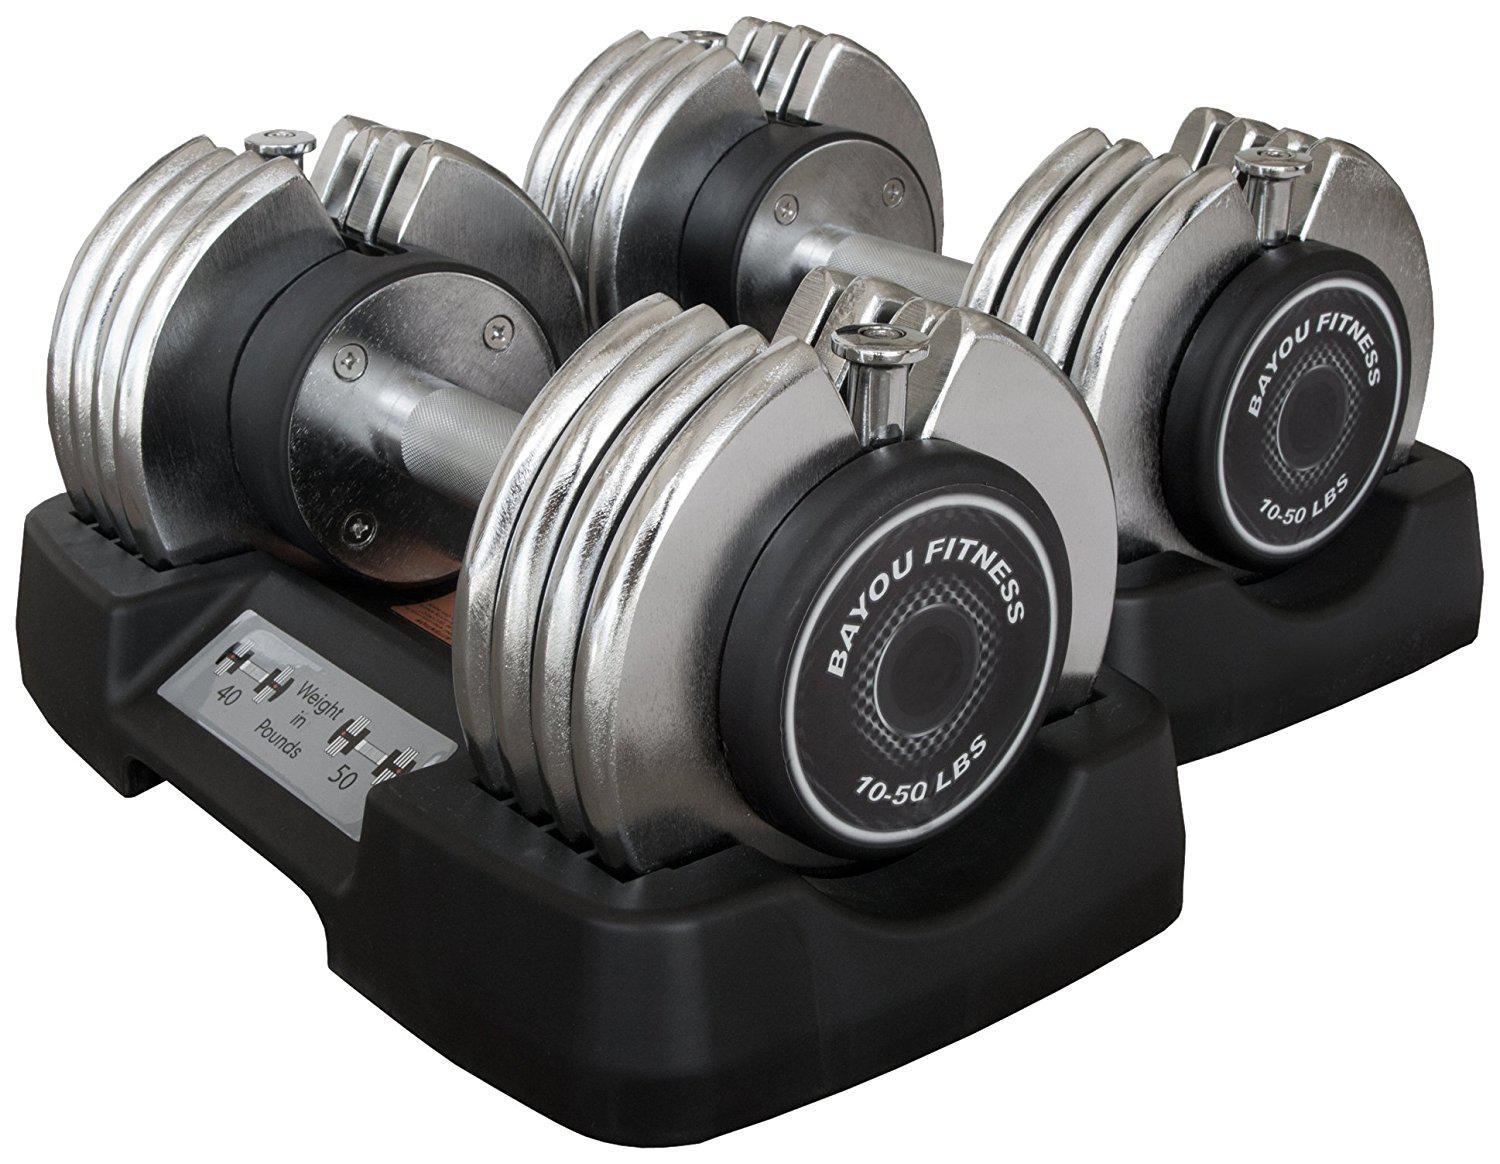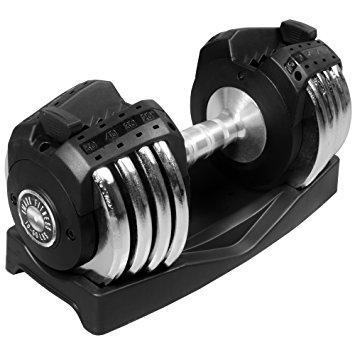The first image is the image on the left, the second image is the image on the right. For the images shown, is this caption "There are exactly three weights with no bars sticking out of them." true? Answer yes or no. Yes. The first image is the image on the left, the second image is the image on the right. Evaluate the accuracy of this statement regarding the images: "There are 3 dumbbells, and all of them are on storage trays.". Is it true? Answer yes or no. Yes. 